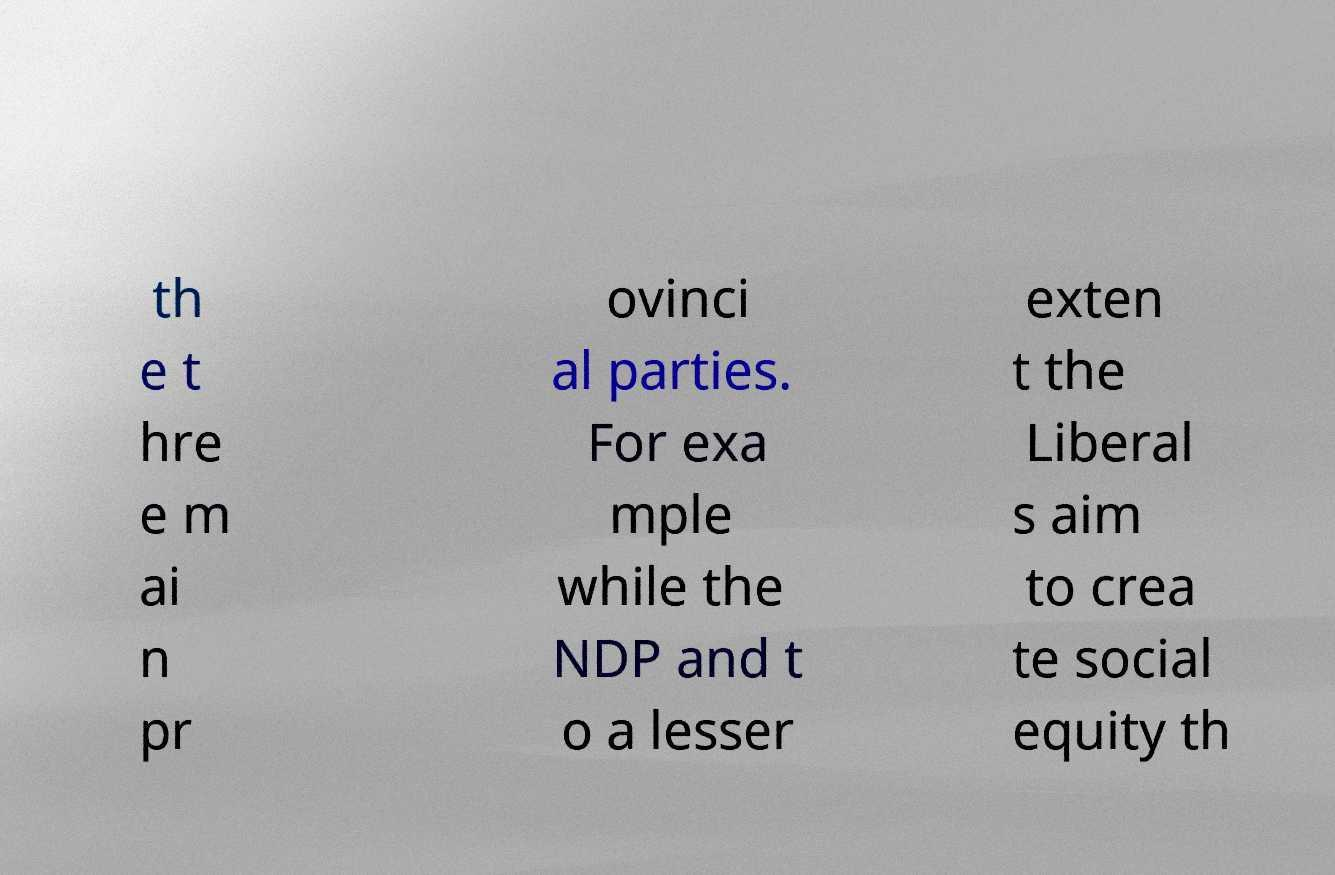Please read and relay the text visible in this image. What does it say? th e t hre e m ai n pr ovinci al parties. For exa mple while the NDP and t o a lesser exten t the Liberal s aim to crea te social equity th 